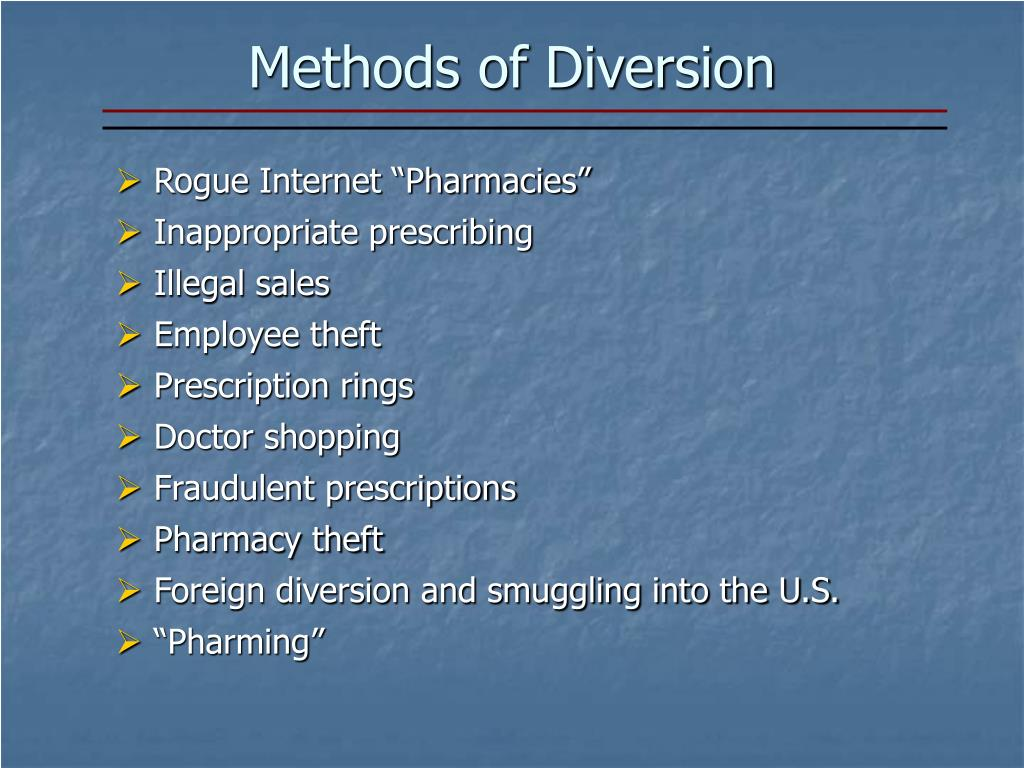Imagine a futuristic method to prevent 'Foreign diversion and smuggling into the U.S.' What would it look like? Imagine a future where each prescription drug is embedded with a tiny, tamper-proof RFID chip that communicates with a global satellite network. This network would track the location and status of each drug in real-time, from manufacturing to the point of sale. If a drug is diverted from its intended path, an alert would be triggered, notifying law enforcement agencies across the globe instantly. Additionally, the system would be integrated with AI that could predict smuggling attempts based on historical data and real-time analytics. It could even deploy autonomous drones to intercept suspicious shipments. This system would be highly secure, with multiple layers of encryption and authentication protocols to prevent hacking. Such a futuristic approach could provide a comprehensive and proactive solution to the complex issue of 'Foreign diversion and smuggling into the U.S.'. 